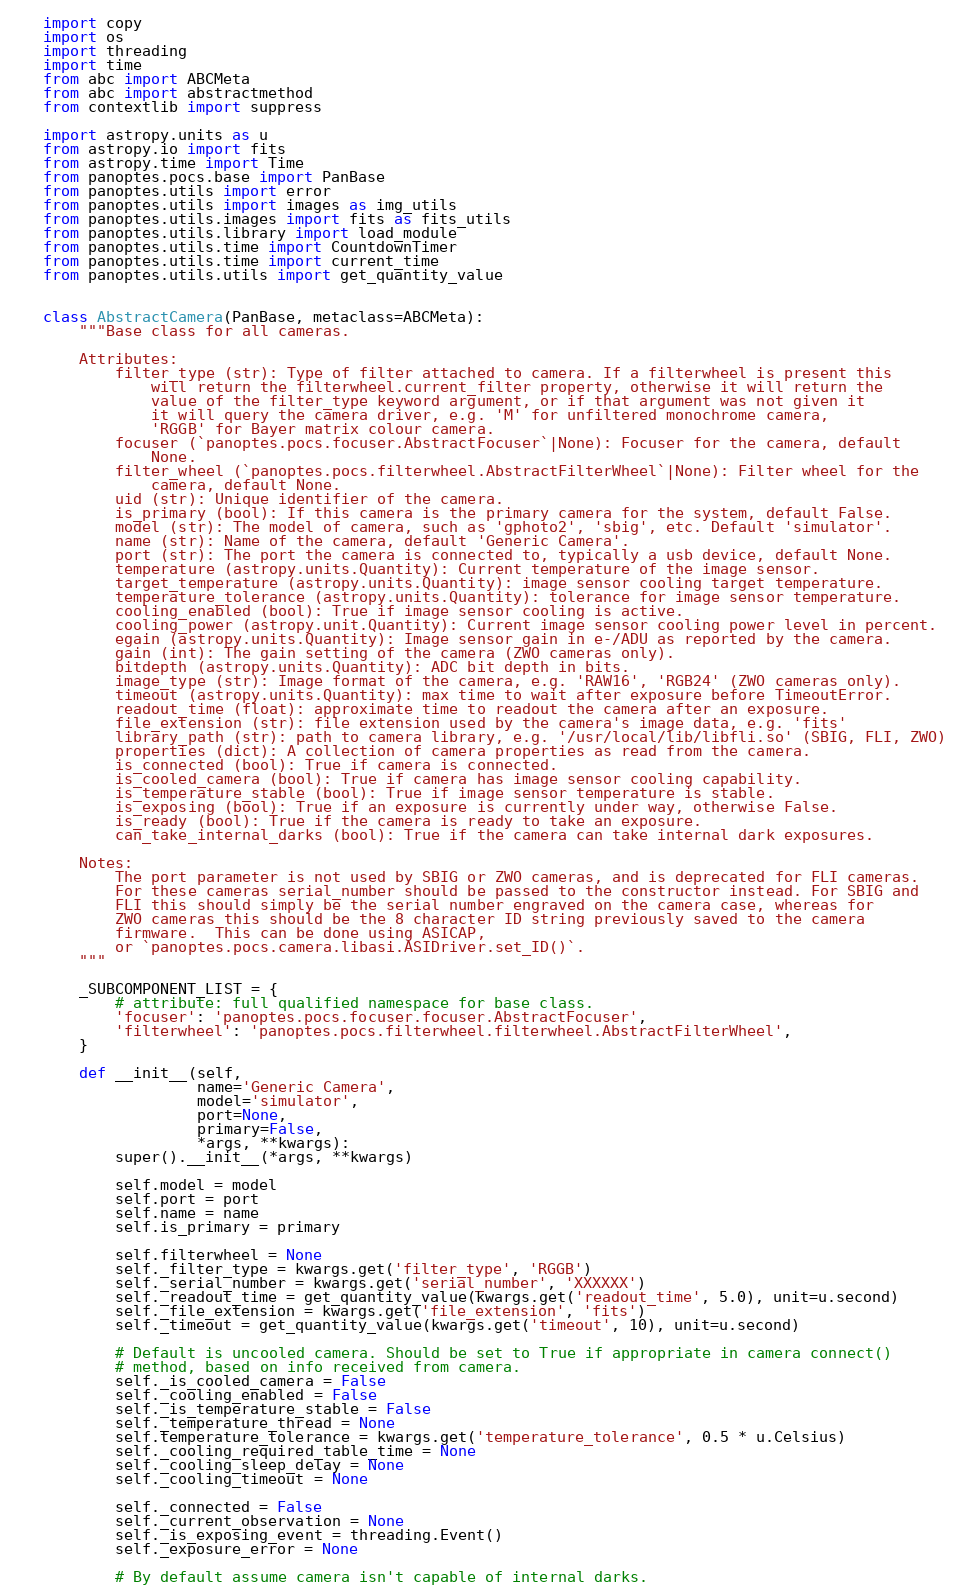Convert code to text. <code><loc_0><loc_0><loc_500><loc_500><_Python_>import copy
import os
import threading
import time
from abc import ABCMeta
from abc import abstractmethod
from contextlib import suppress

import astropy.units as u
from astropy.io import fits
from astropy.time import Time
from panoptes.pocs.base import PanBase
from panoptes.utils import error
from panoptes.utils import images as img_utils
from panoptes.utils.images import fits as fits_utils
from panoptes.utils.library import load_module
from panoptes.utils.time import CountdownTimer
from panoptes.utils.time import current_time
from panoptes.utils.utils import get_quantity_value


class AbstractCamera(PanBase, metaclass=ABCMeta):
    """Base class for all cameras.

    Attributes:
        filter_type (str): Type of filter attached to camera. If a filterwheel is present this
            will return the filterwheel.current_filter property, otherwise it will return the
            value of the filter_type keyword argument, or if that argument was not given it
            it will query the camera driver, e.g. 'M' for unfiltered monochrome camera,
            'RGGB' for Bayer matrix colour camera.
        focuser (`panoptes.pocs.focuser.AbstractFocuser`|None): Focuser for the camera, default
            None.
        filter_wheel (`panoptes.pocs.filterwheel.AbstractFilterWheel`|None): Filter wheel for the
            camera, default None.
        uid (str): Unique identifier of the camera.
        is_primary (bool): If this camera is the primary camera for the system, default False.
        model (str): The model of camera, such as 'gphoto2', 'sbig', etc. Default 'simulator'.
        name (str): Name of the camera, default 'Generic Camera'.
        port (str): The port the camera is connected to, typically a usb device, default None.
        temperature (astropy.units.Quantity): Current temperature of the image sensor.
        target_temperature (astropy.units.Quantity): image sensor cooling target temperature.
        temperature_tolerance (astropy.units.Quantity): tolerance for image sensor temperature.
        cooling_enabled (bool): True if image sensor cooling is active.
        cooling_power (astropy.unit.Quantity): Current image sensor cooling power level in percent.
        egain (astropy.units.Quantity): Image sensor gain in e-/ADU as reported by the camera.
        gain (int): The gain setting of the camera (ZWO cameras only).
        bitdepth (astropy.units.Quantity): ADC bit depth in bits.
        image_type (str): Image format of the camera, e.g. 'RAW16', 'RGB24' (ZWO cameras only).
        timeout (astropy.units.Quantity): max time to wait after exposure before TimeoutError.
        readout_time (float): approximate time to readout the camera after an exposure.
        file_extension (str): file extension used by the camera's image data, e.g. 'fits'
        library_path (str): path to camera library, e.g. '/usr/local/lib/libfli.so' (SBIG, FLI, ZWO)
        properties (dict): A collection of camera properties as read from the camera.
        is_connected (bool): True if camera is connected.
        is_cooled_camera (bool): True if camera has image sensor cooling capability.
        is_temperature_stable (bool): True if image sensor temperature is stable.
        is_exposing (bool): True if an exposure is currently under way, otherwise False.
        is_ready (bool): True if the camera is ready to take an exposure.
        can_take_internal_darks (bool): True if the camera can take internal dark exposures.

    Notes:
        The port parameter is not used by SBIG or ZWO cameras, and is deprecated for FLI cameras.
        For these cameras serial_number should be passed to the constructor instead. For SBIG and
        FLI this should simply be the serial number engraved on the camera case, whereas for
        ZWO cameras this should be the 8 character ID string previously saved to the camera
        firmware.  This can be done using ASICAP,
        or `panoptes.pocs.camera.libasi.ASIDriver.set_ID()`.
    """

    _SUBCOMPONENT_LIST = {
        # attribute: full qualified namespace for base class.
        'focuser': 'panoptes.pocs.focuser.focuser.AbstractFocuser',
        'filterwheel': 'panoptes.pocs.filterwheel.filterwheel.AbstractFilterWheel',
    }

    def __init__(self,
                 name='Generic Camera',
                 model='simulator',
                 port=None,
                 primary=False,
                 *args, **kwargs):
        super().__init__(*args, **kwargs)

        self.model = model
        self.port = port
        self.name = name
        self.is_primary = primary

        self.filterwheel = None
        self._filter_type = kwargs.get('filter_type', 'RGGB')
        self._serial_number = kwargs.get('serial_number', 'XXXXXX')
        self._readout_time = get_quantity_value(kwargs.get('readout_time', 5.0), unit=u.second)
        self._file_extension = kwargs.get('file_extension', 'fits')
        self._timeout = get_quantity_value(kwargs.get('timeout', 10), unit=u.second)

        # Default is uncooled camera. Should be set to True if appropriate in camera connect()
        # method, based on info received from camera.
        self._is_cooled_camera = False
        self._cooling_enabled = False
        self._is_temperature_stable = False
        self._temperature_thread = None
        self.temperature_tolerance = kwargs.get('temperature_tolerance', 0.5 * u.Celsius)
        self._cooling_required_table_time = None
        self._cooling_sleep_delay = None
        self._cooling_timeout = None

        self._connected = False
        self._current_observation = None
        self._is_exposing_event = threading.Event()
        self._exposure_error = None

        # By default assume camera isn't capable of internal darks.</code> 